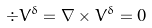<formula> <loc_0><loc_0><loc_500><loc_500>\div { V ^ { \delta } } = \nabla \times { V ^ { \delta } } = 0</formula> 